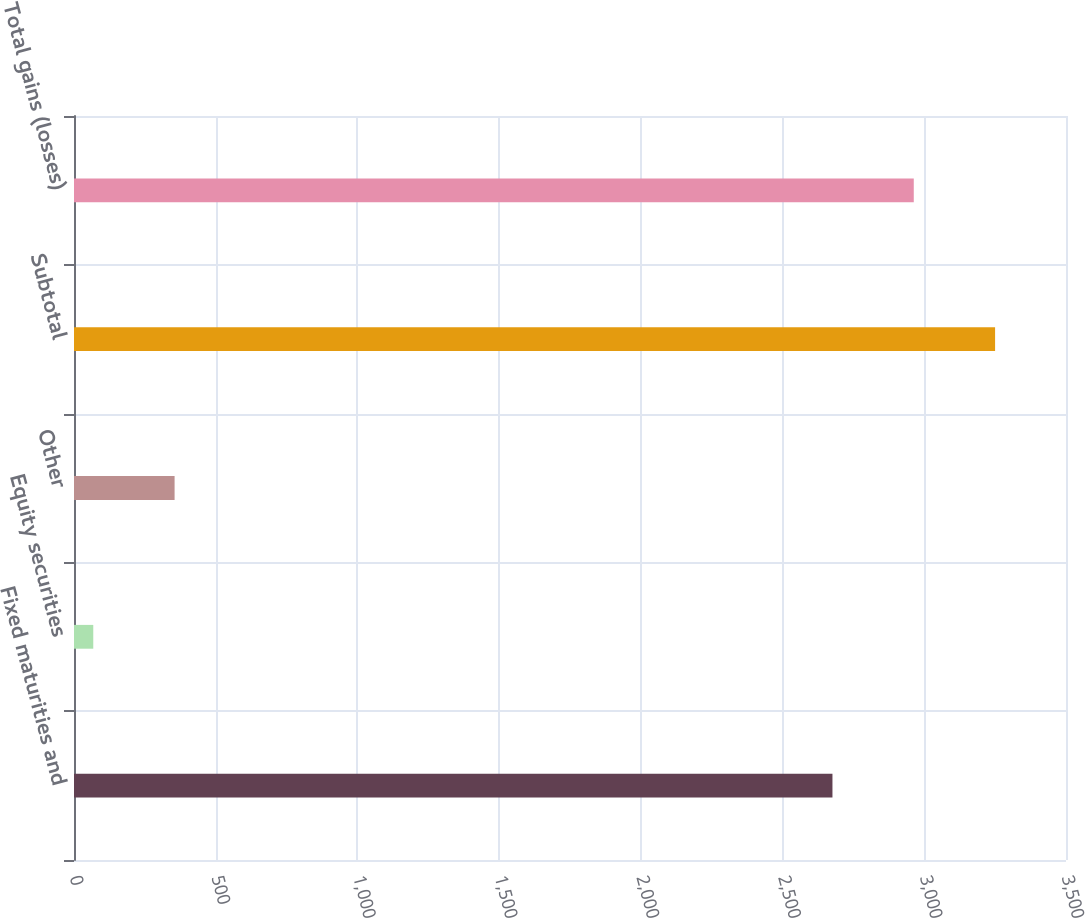<chart> <loc_0><loc_0><loc_500><loc_500><bar_chart><fcel>Fixed maturities and<fcel>Equity securities<fcel>Other<fcel>Subtotal<fcel>Total gains (losses)<nl><fcel>2676<fcel>68<fcel>354.9<fcel>3249.8<fcel>2962.9<nl></chart> 